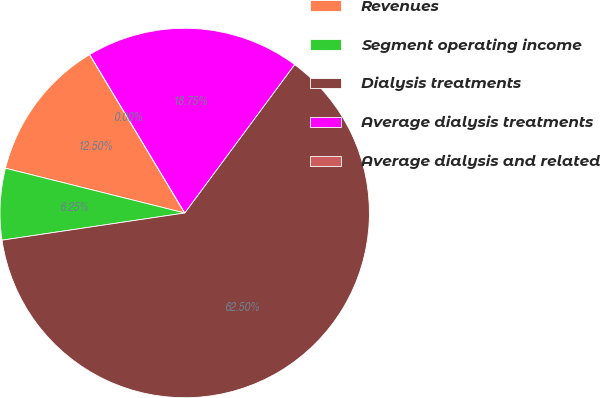Convert chart to OTSL. <chart><loc_0><loc_0><loc_500><loc_500><pie_chart><fcel>Revenues<fcel>Segment operating income<fcel>Dialysis treatments<fcel>Average dialysis treatments<fcel>Average dialysis and related<nl><fcel>12.5%<fcel>6.25%<fcel>62.5%<fcel>18.75%<fcel>0.0%<nl></chart> 